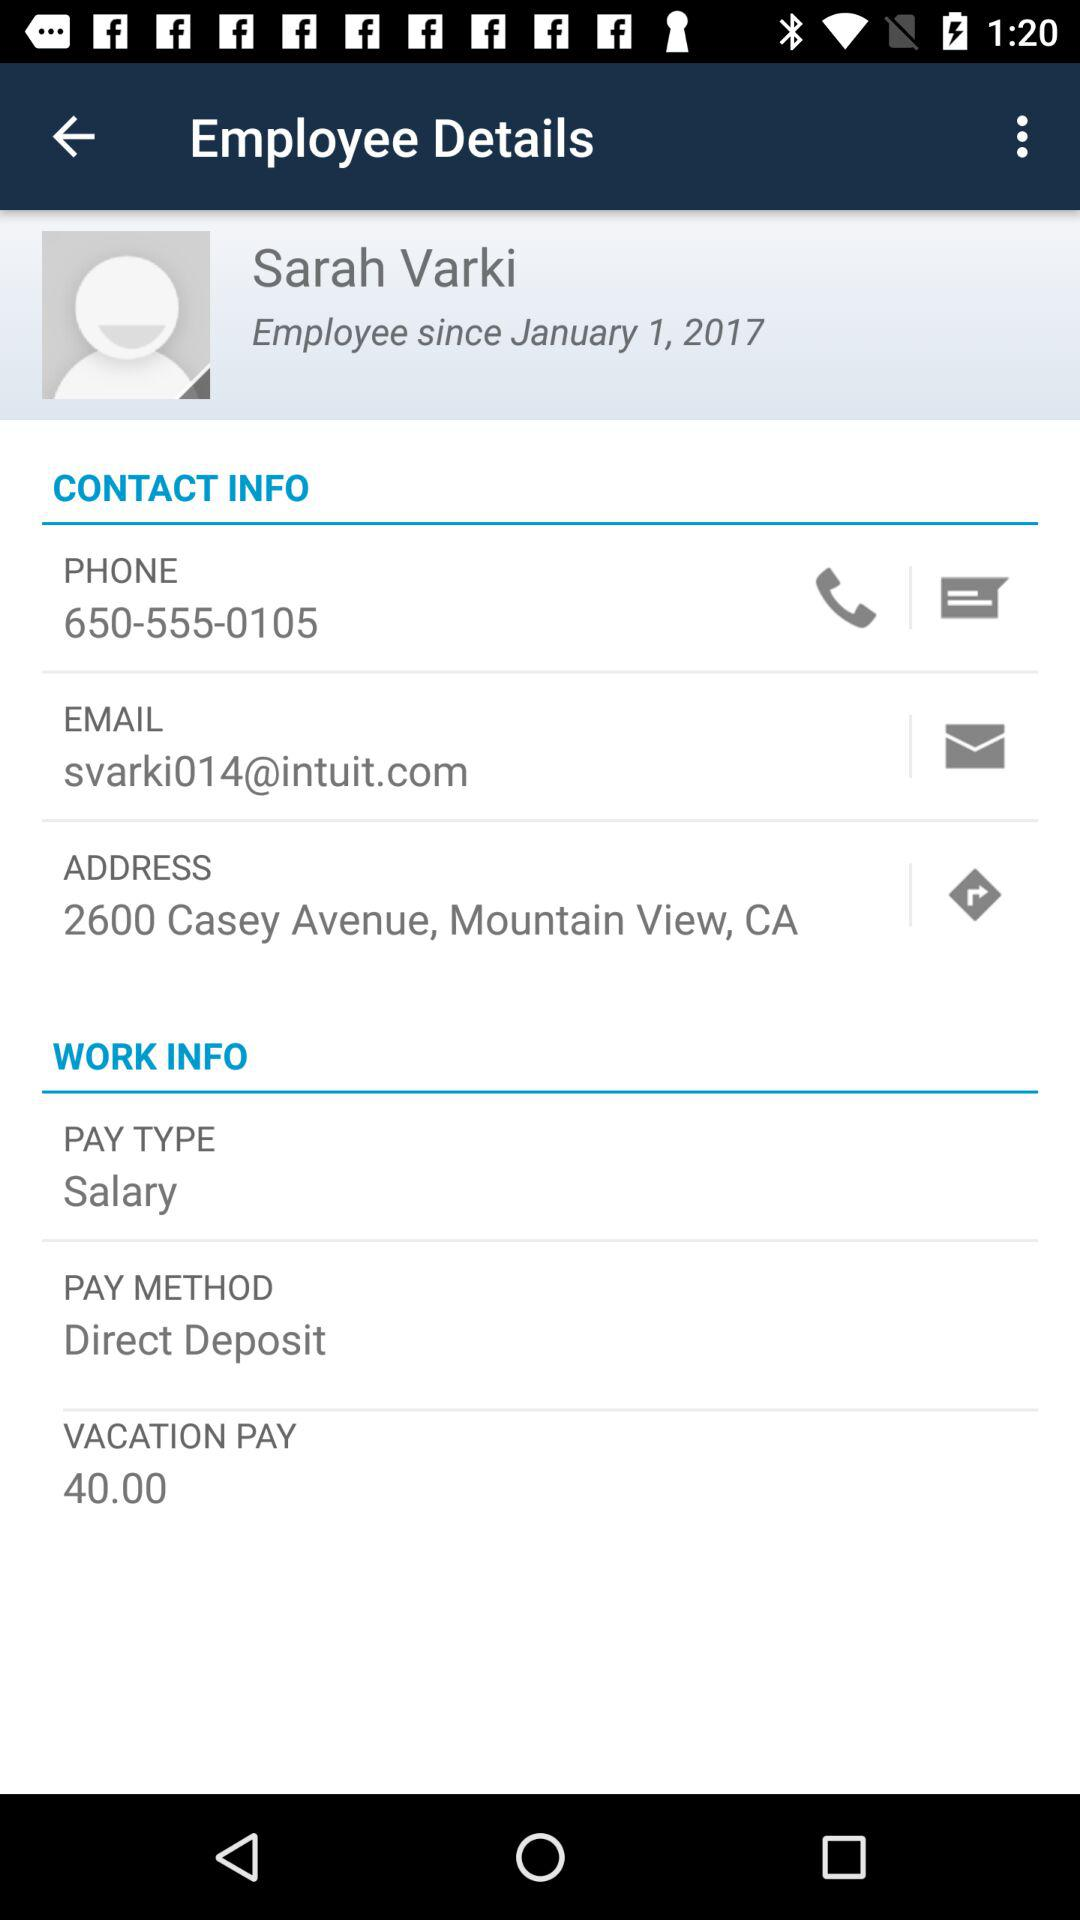What is the employee name? The employee name is Sarah Varki. 